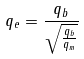<formula> <loc_0><loc_0><loc_500><loc_500>q _ { e } = \frac { q _ { b } } { \sqrt { \frac { q _ { b } } { q _ { m } } } }</formula> 